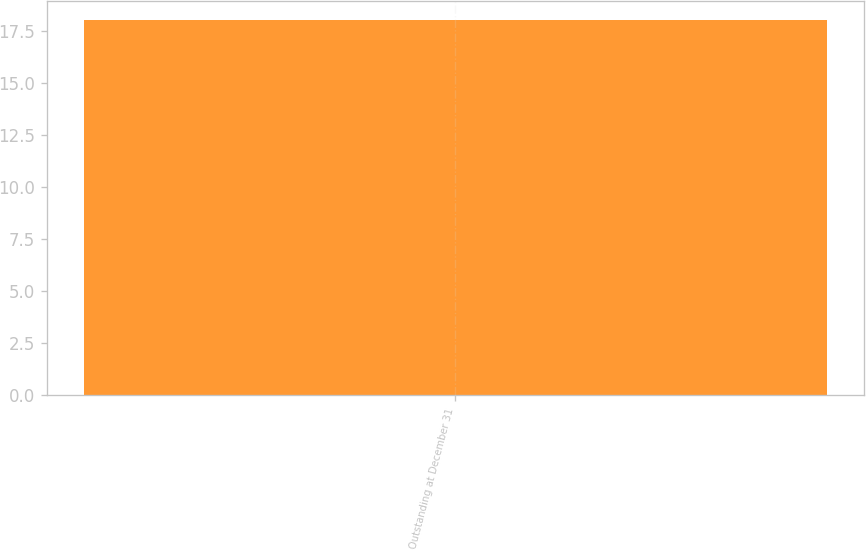Convert chart. <chart><loc_0><loc_0><loc_500><loc_500><bar_chart><fcel>Outstanding at December 31<nl><fcel>18.05<nl></chart> 